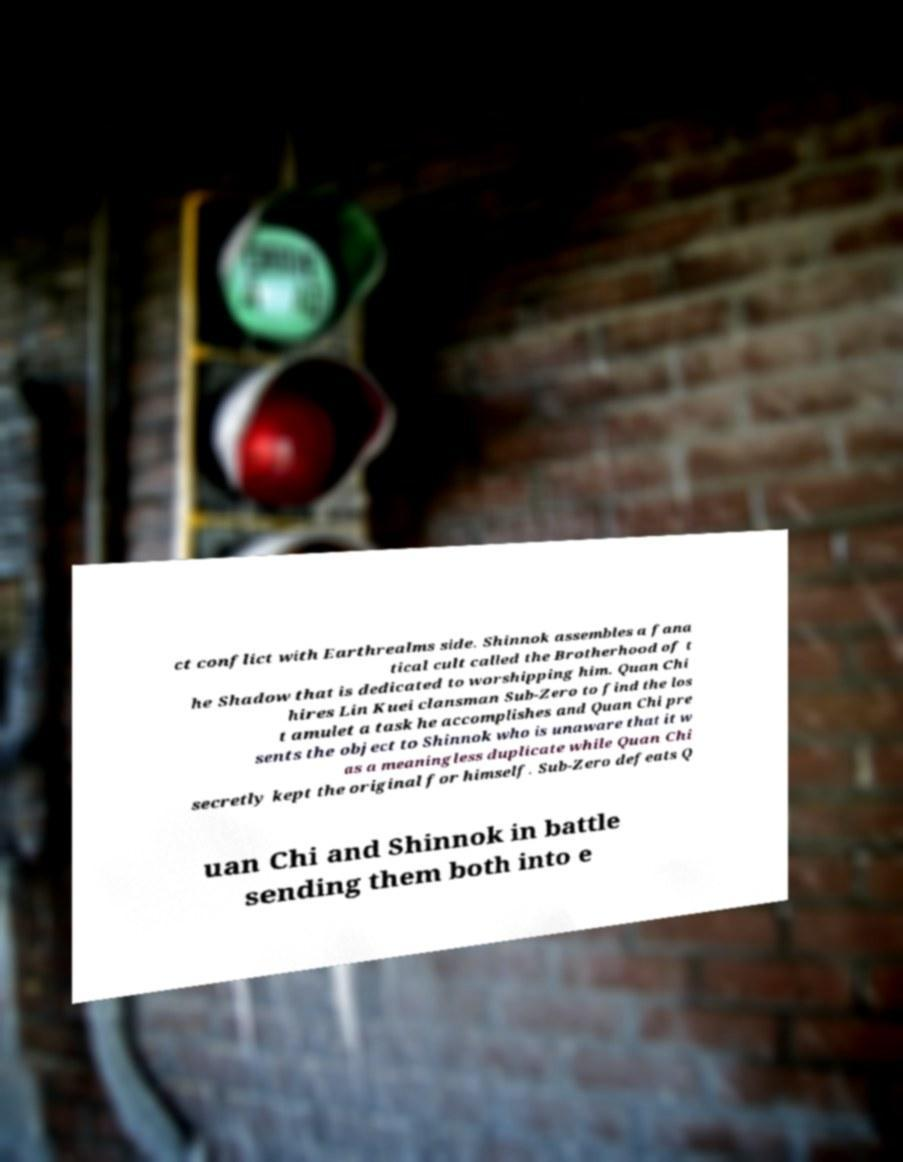What messages or text are displayed in this image? I need them in a readable, typed format. ct conflict with Earthrealms side. Shinnok assembles a fana tical cult called the Brotherhood of t he Shadow that is dedicated to worshipping him. Quan Chi hires Lin Kuei clansman Sub-Zero to find the los t amulet a task he accomplishes and Quan Chi pre sents the object to Shinnok who is unaware that it w as a meaningless duplicate while Quan Chi secretly kept the original for himself. Sub-Zero defeats Q uan Chi and Shinnok in battle sending them both into e 